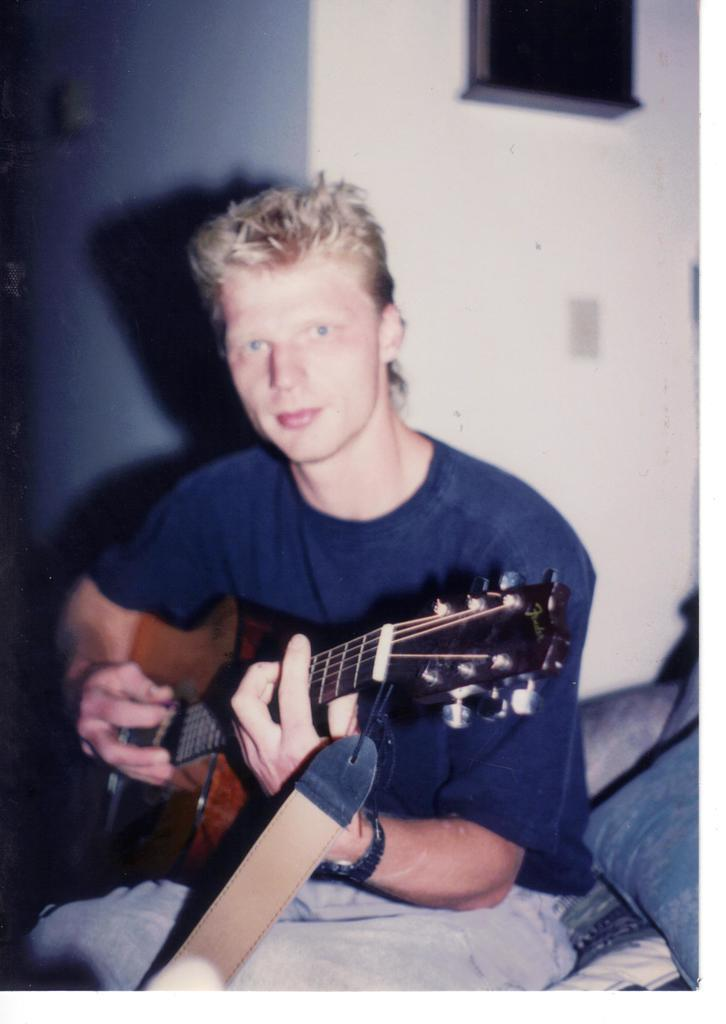What is the person in the image doing? The person is holding a guitar. What is the person wearing in the image? The person is wearing a blue color t-shirt. Where is the person sitting in the image? The person is sitting on a bed. What is present on the bed besides the person? There is a pillow on the bed. What can be seen behind the person in the image? There is a wall behind the person. What type of jewel is the person wearing on their neck in the image? There is no jewel visible around the person's neck in the image. What type of substance can be seen dripping from the guitar in the image? There is no substance dripping from the guitar in the image. 